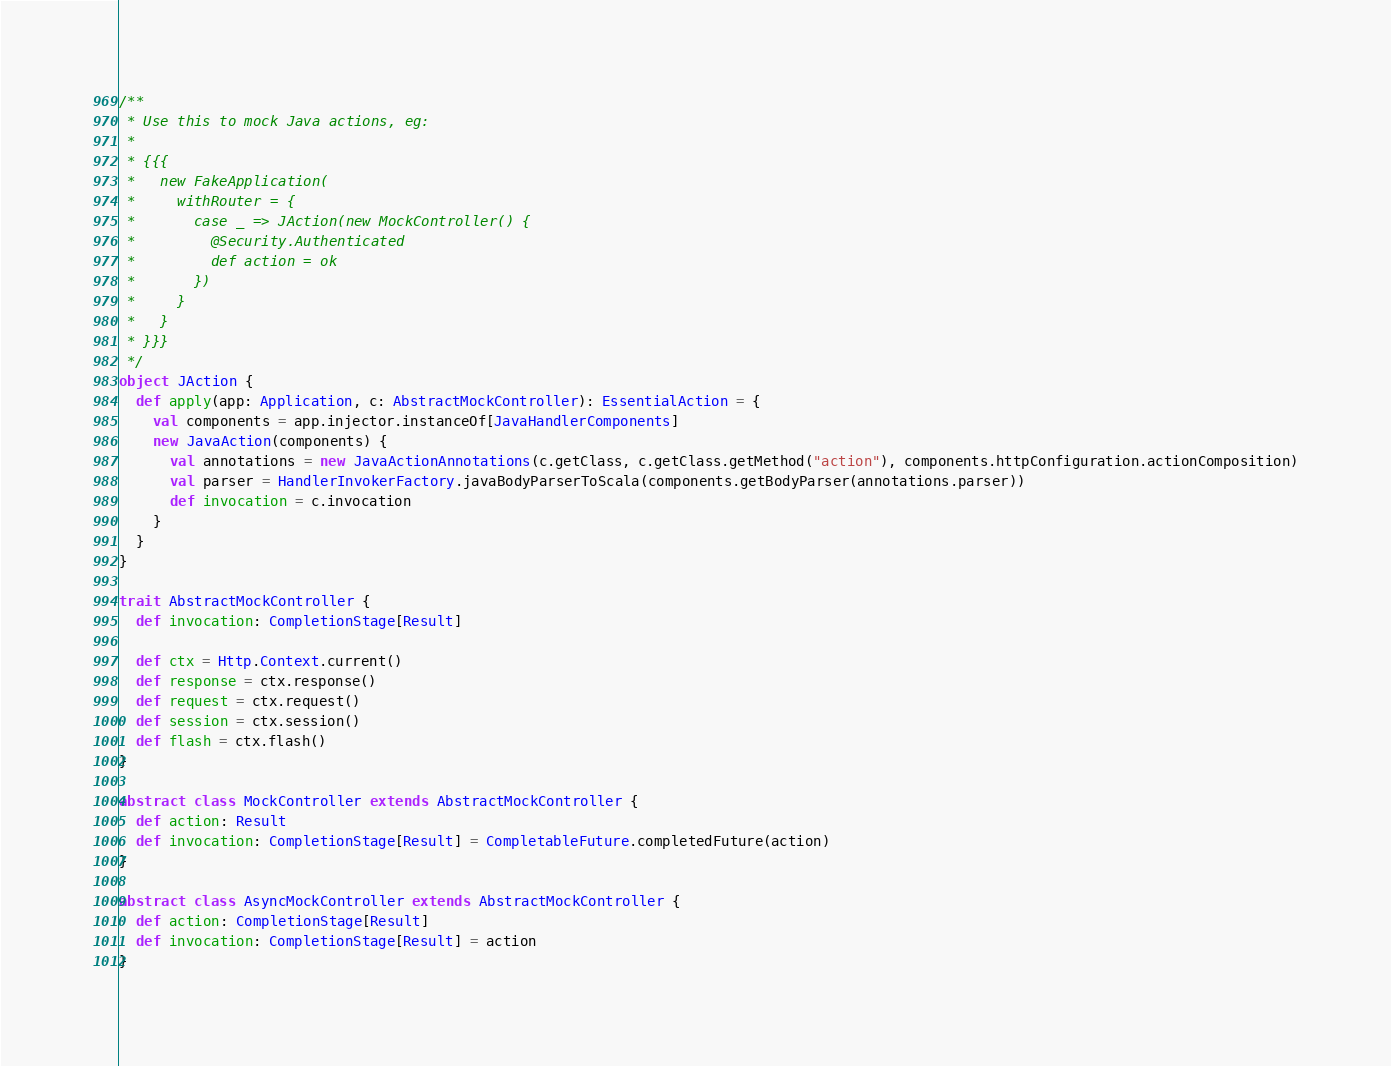Convert code to text. <code><loc_0><loc_0><loc_500><loc_500><_Scala_>/**
 * Use this to mock Java actions, eg:
 *
 * {{{
 *   new FakeApplication(
 *     withRouter = {
 *       case _ => JAction(new MockController() {
 *         @Security.Authenticated
 *         def action = ok
 *       })
 *     }
 *   }
 * }}}
 */
object JAction {
  def apply(app: Application, c: AbstractMockController): EssentialAction = {
    val components = app.injector.instanceOf[JavaHandlerComponents]
    new JavaAction(components) {
      val annotations = new JavaActionAnnotations(c.getClass, c.getClass.getMethod("action"), components.httpConfiguration.actionComposition)
      val parser = HandlerInvokerFactory.javaBodyParserToScala(components.getBodyParser(annotations.parser))
      def invocation = c.invocation
    }
  }
}

trait AbstractMockController {
  def invocation: CompletionStage[Result]

  def ctx = Http.Context.current()
  def response = ctx.response()
  def request = ctx.request()
  def session = ctx.session()
  def flash = ctx.flash()
}

abstract class MockController extends AbstractMockController {
  def action: Result
  def invocation: CompletionStage[Result] = CompletableFuture.completedFuture(action)
}

abstract class AsyncMockController extends AbstractMockController {
  def action: CompletionStage[Result]
  def invocation: CompletionStage[Result] = action
}
</code> 